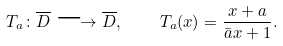<formula> <loc_0><loc_0><loc_500><loc_500>T _ { a } \colon \overline { D } \longrightarrow \overline { D } , \quad T _ { a } ( x ) = \frac { x + a } { \bar { a } x + 1 } .</formula> 